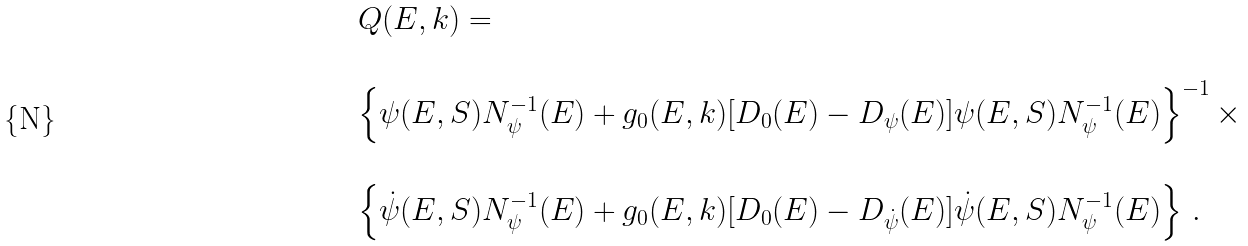<formula> <loc_0><loc_0><loc_500><loc_500>\begin{array} { l } Q ( E , k ) = \\ \\ \left \{ \psi ( E , S ) N _ { \psi } ^ { - 1 } ( E ) + g _ { 0 } ( E , k ) [ D _ { 0 } ( E ) - D _ { \psi } ( E ) ] \psi ( E , S ) N _ { \psi } ^ { - 1 } ( E ) \right \} ^ { - 1 } \times \\ \\ \left \{ \dot { \psi } ( E , S ) N _ { \psi } ^ { - 1 } ( E ) + g _ { 0 } ( E , k ) [ D _ { 0 } ( E ) - D _ { \dot { \psi } } ( E ) ] \dot { \psi } ( E , S ) N _ { \psi } ^ { - 1 } ( E ) \right \} \, . \end{array}</formula> 